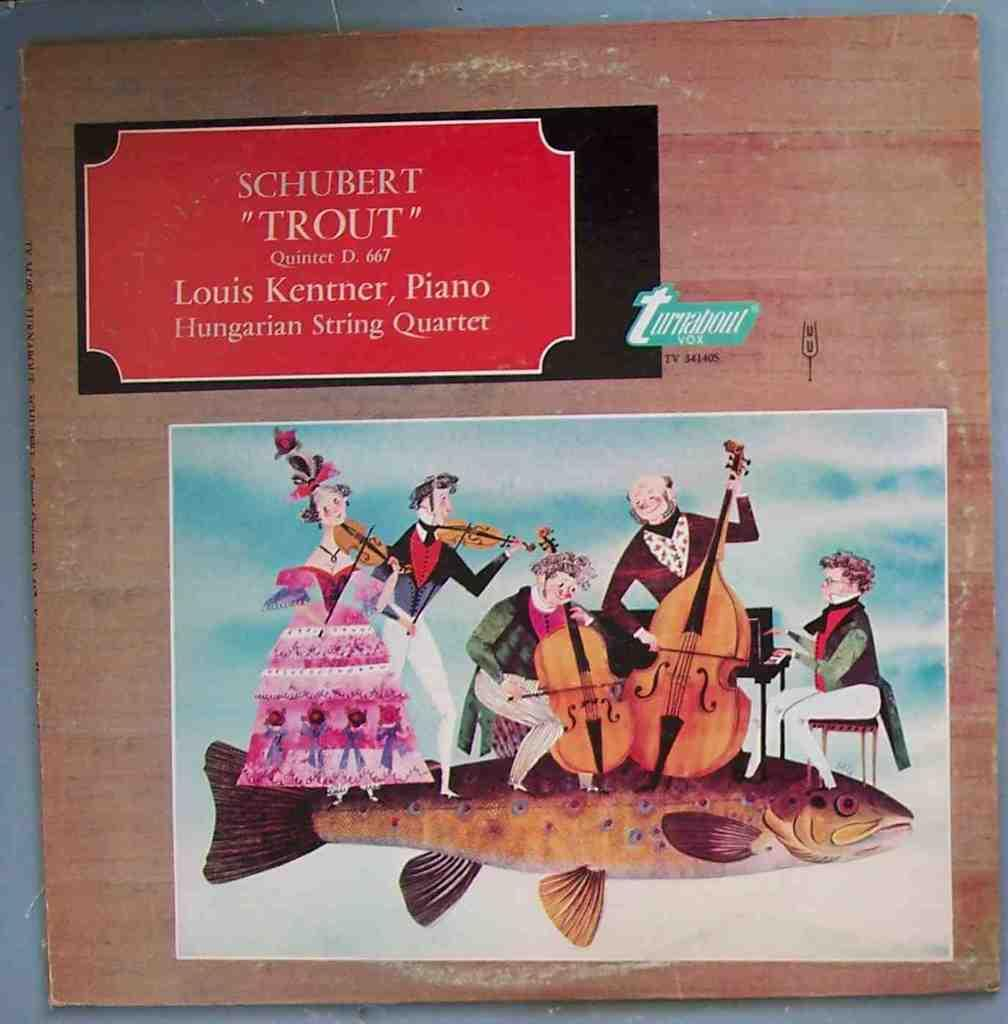<image>
Offer a succinct explanation of the picture presented. A picture named, "Trout" by Louis Kentner Piano. 